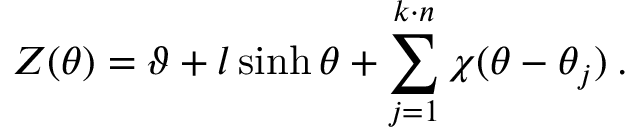Convert formula to latex. <formula><loc_0><loc_0><loc_500><loc_500>Z ( \theta ) = \vartheta + l \sinh \theta + \sum _ { j = 1 } ^ { k \cdot n } \chi ( \theta - \theta _ { j } ) \, .</formula> 